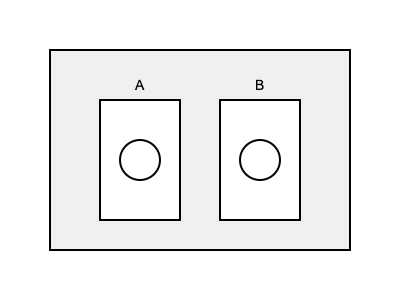In the illustration above, which area (A or B) represents the correct placement for lab coats and safety goggles in a chemistry laboratory setting? To determine the correct placement for lab coats and safety goggles in a chemistry laboratory setting, we need to consider the following steps:

1. Accessibility: Safety equipment should be easily accessible to all lab users.
2. Visibility: The storage area should be clearly visible and identifiable.
3. Contamination risk: The storage area should minimize the risk of contamination from chemical spills or other hazards.
4. Proximity to lab entrance: Safety equipment should be located near the lab entrance for immediate use upon entering.

Analyzing the illustration:

Area A:
- Located closer to the left side of the room
- May be less accessible to all lab users
- Potentially farther from the lab entrance

Area B:
- Located closer to the right side of the room
- Likely more accessible to all lab users
- Potentially closer to the lab entrance

Based on these observations, Area B is more likely to represent the correct placement for lab coats and safety goggles because:

1. It appears to be more centrally located, improving accessibility for all lab users.
2. Its position suggests it may be closer to the lab entrance, allowing for immediate access upon entering the lab.
3. The central location reduces the risk of contamination from potential spills or hazards in other parts of the lab.

Therefore, Area B represents the correct placement for lab coats and safety goggles in this chemistry laboratory setting.
Answer: B 